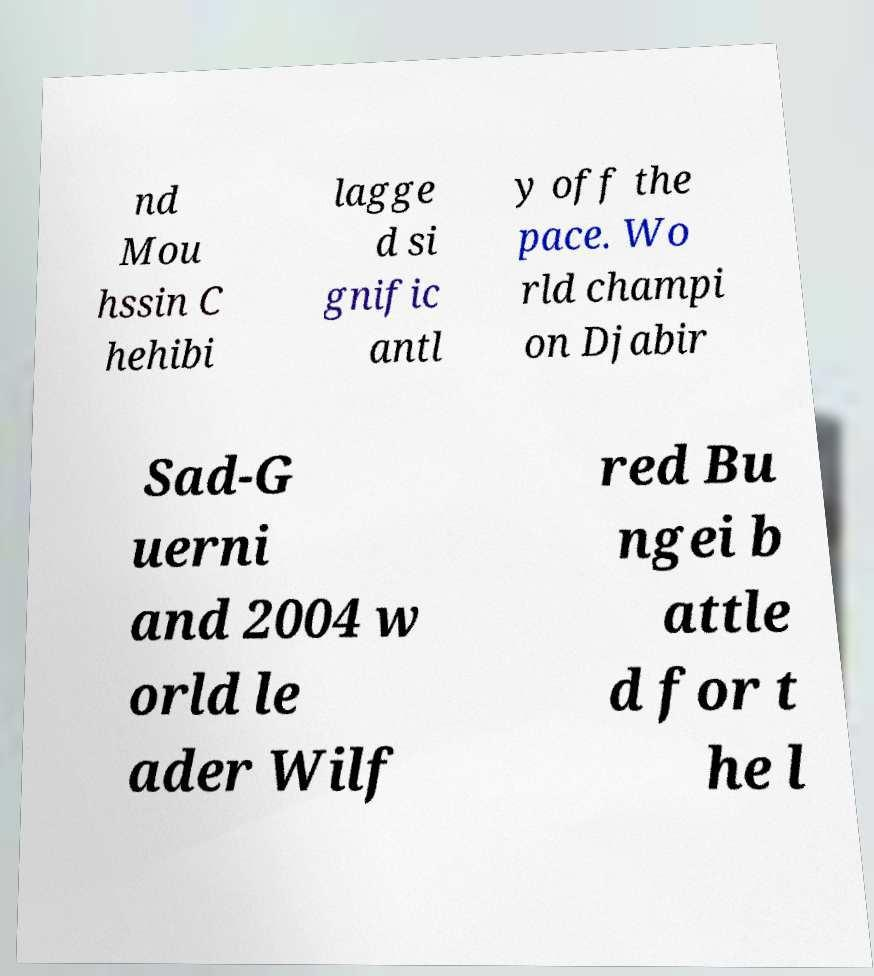Please read and relay the text visible in this image. What does it say? nd Mou hssin C hehibi lagge d si gnific antl y off the pace. Wo rld champi on Djabir Sad-G uerni and 2004 w orld le ader Wilf red Bu ngei b attle d for t he l 